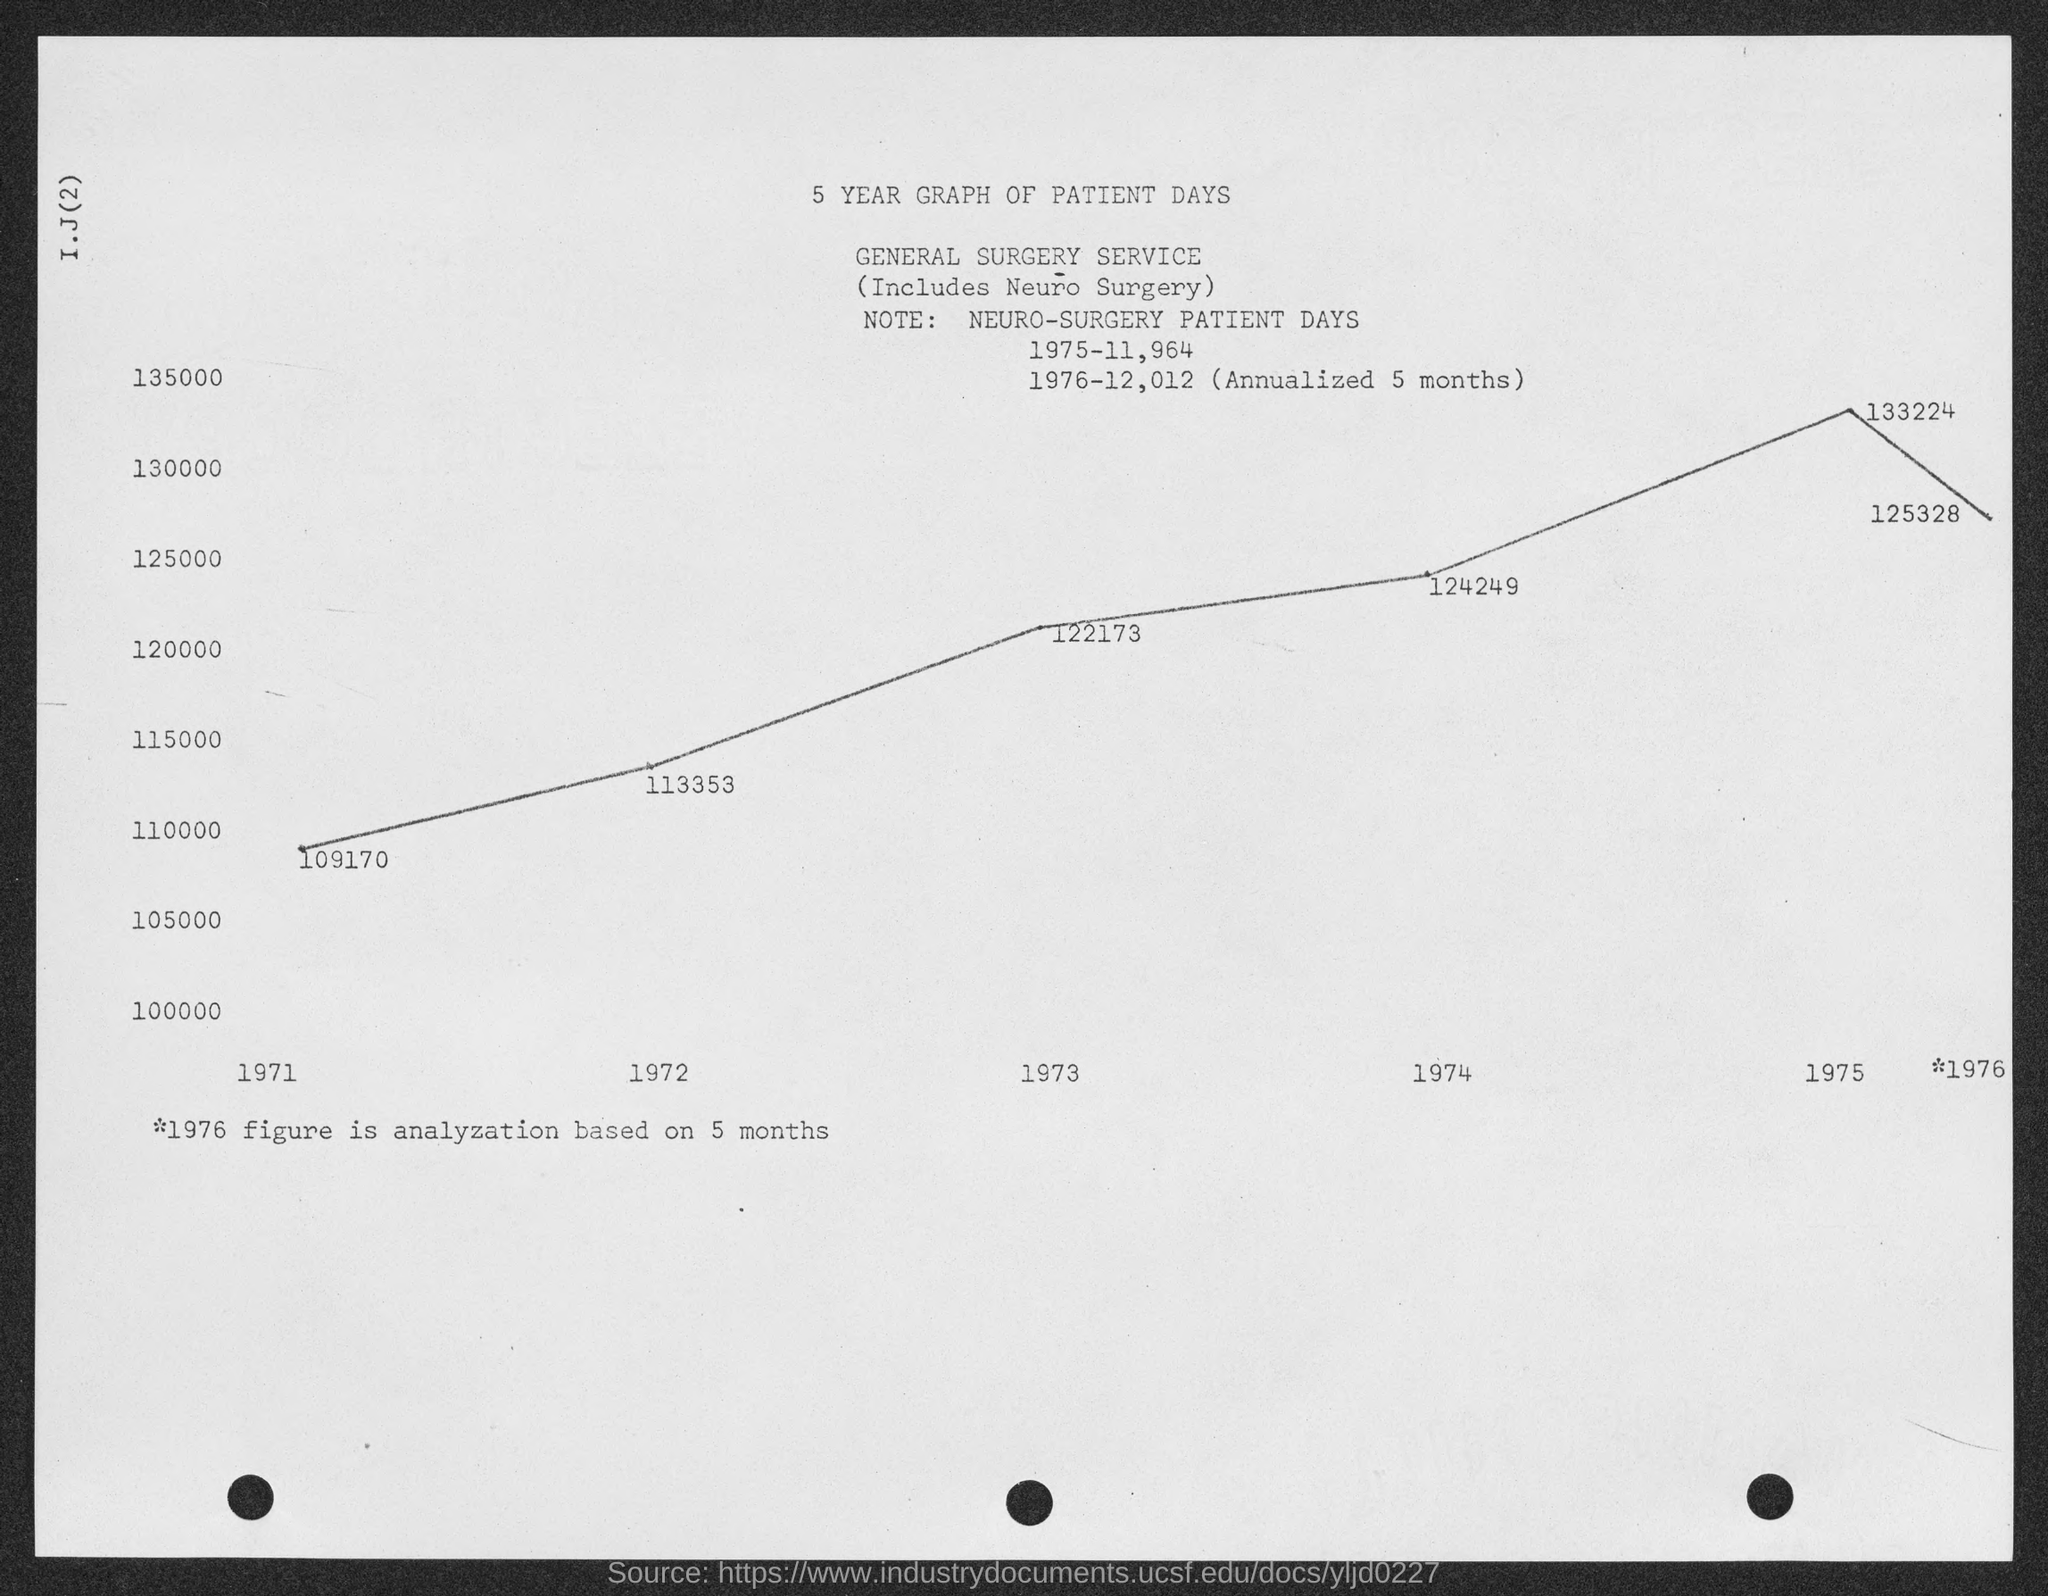List a handful of essential elements in this visual. The first title in the document is "5 YEAR GRAPH OF PATIENT DAYS..". The lowest value plotted on the graph is 109170. The second title in the document is 'GENERAL SURGERY SERVICE.' The highest value plotted on the graph is 133,224. 